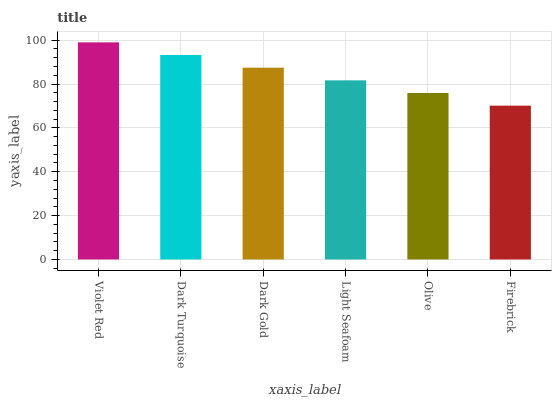Is Firebrick the minimum?
Answer yes or no. Yes. Is Violet Red the maximum?
Answer yes or no. Yes. Is Dark Turquoise the minimum?
Answer yes or no. No. Is Dark Turquoise the maximum?
Answer yes or no. No. Is Violet Red greater than Dark Turquoise?
Answer yes or no. Yes. Is Dark Turquoise less than Violet Red?
Answer yes or no. Yes. Is Dark Turquoise greater than Violet Red?
Answer yes or no. No. Is Violet Red less than Dark Turquoise?
Answer yes or no. No. Is Dark Gold the high median?
Answer yes or no. Yes. Is Light Seafoam the low median?
Answer yes or no. Yes. Is Dark Turquoise the high median?
Answer yes or no. No. Is Firebrick the low median?
Answer yes or no. No. 